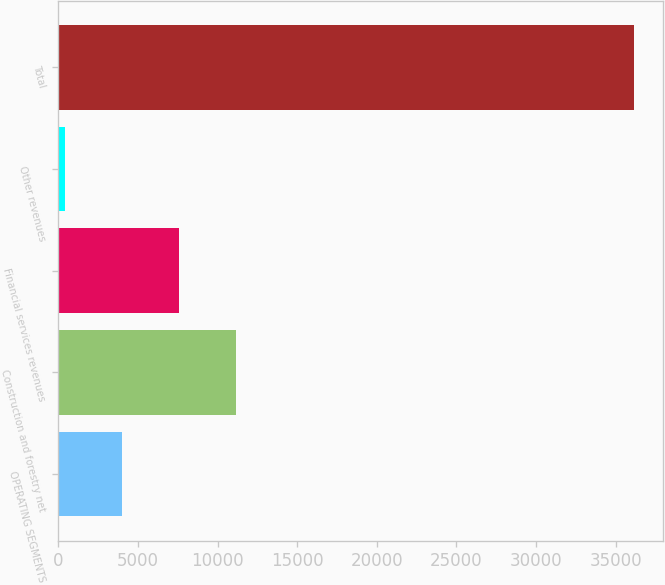<chart> <loc_0><loc_0><loc_500><loc_500><bar_chart><fcel>OPERATING SEGMENTS<fcel>Construction and forestry net<fcel>Financial services revenues<fcel>Other revenues<fcel>Total<nl><fcel>3994.6<fcel>11141.8<fcel>7568.2<fcel>421<fcel>36157<nl></chart> 